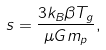Convert formula to latex. <formula><loc_0><loc_0><loc_500><loc_500>s = \frac { 3 k _ { B } \beta T _ { g } } { \mu G m _ { p } } ,</formula> 